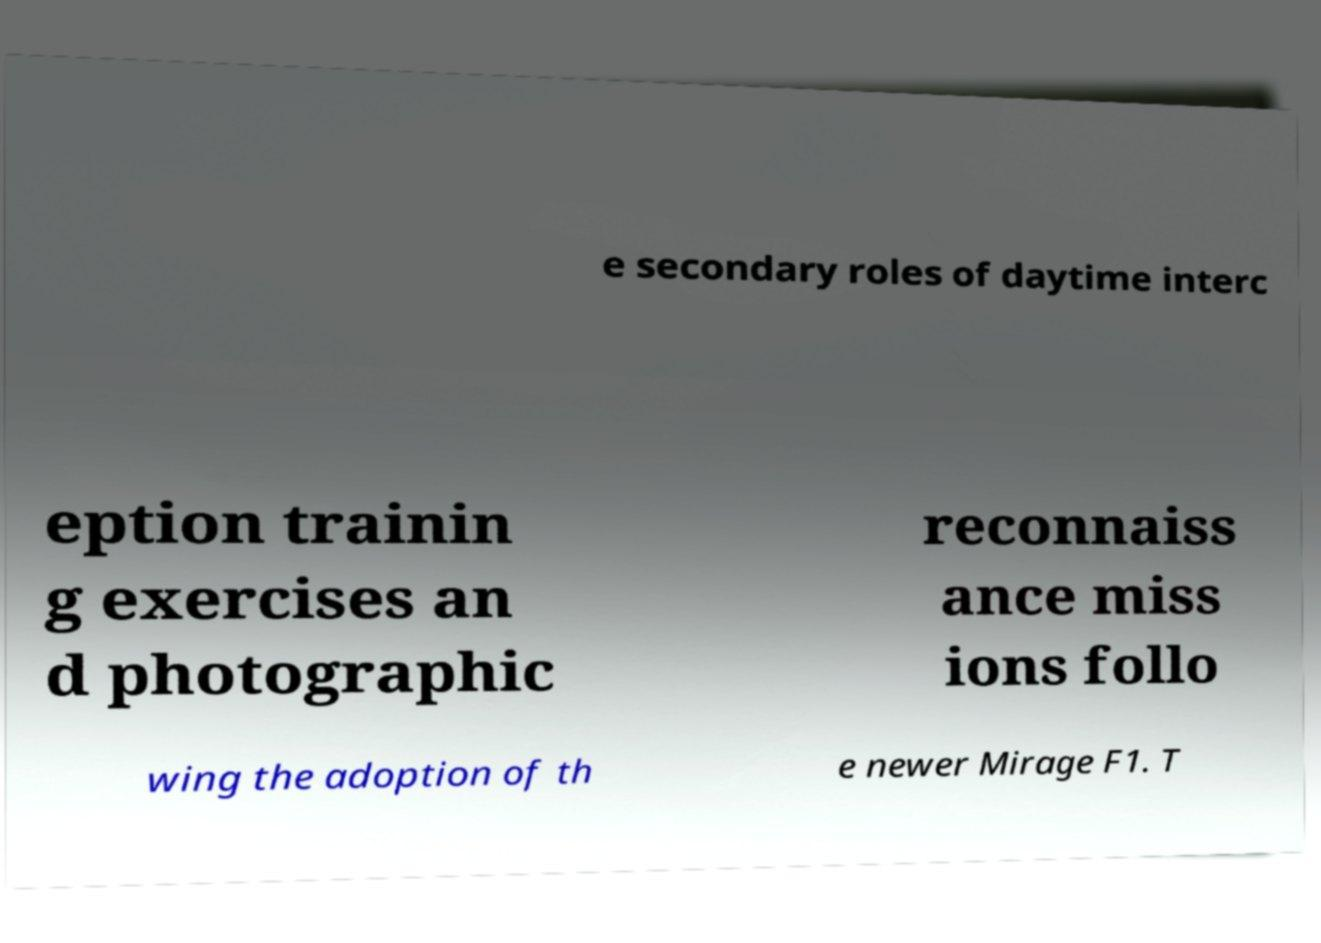Can you read and provide the text displayed in the image?This photo seems to have some interesting text. Can you extract and type it out for me? e secondary roles of daytime interc eption trainin g exercises an d photographic reconnaiss ance miss ions follo wing the adoption of th e newer Mirage F1. T 